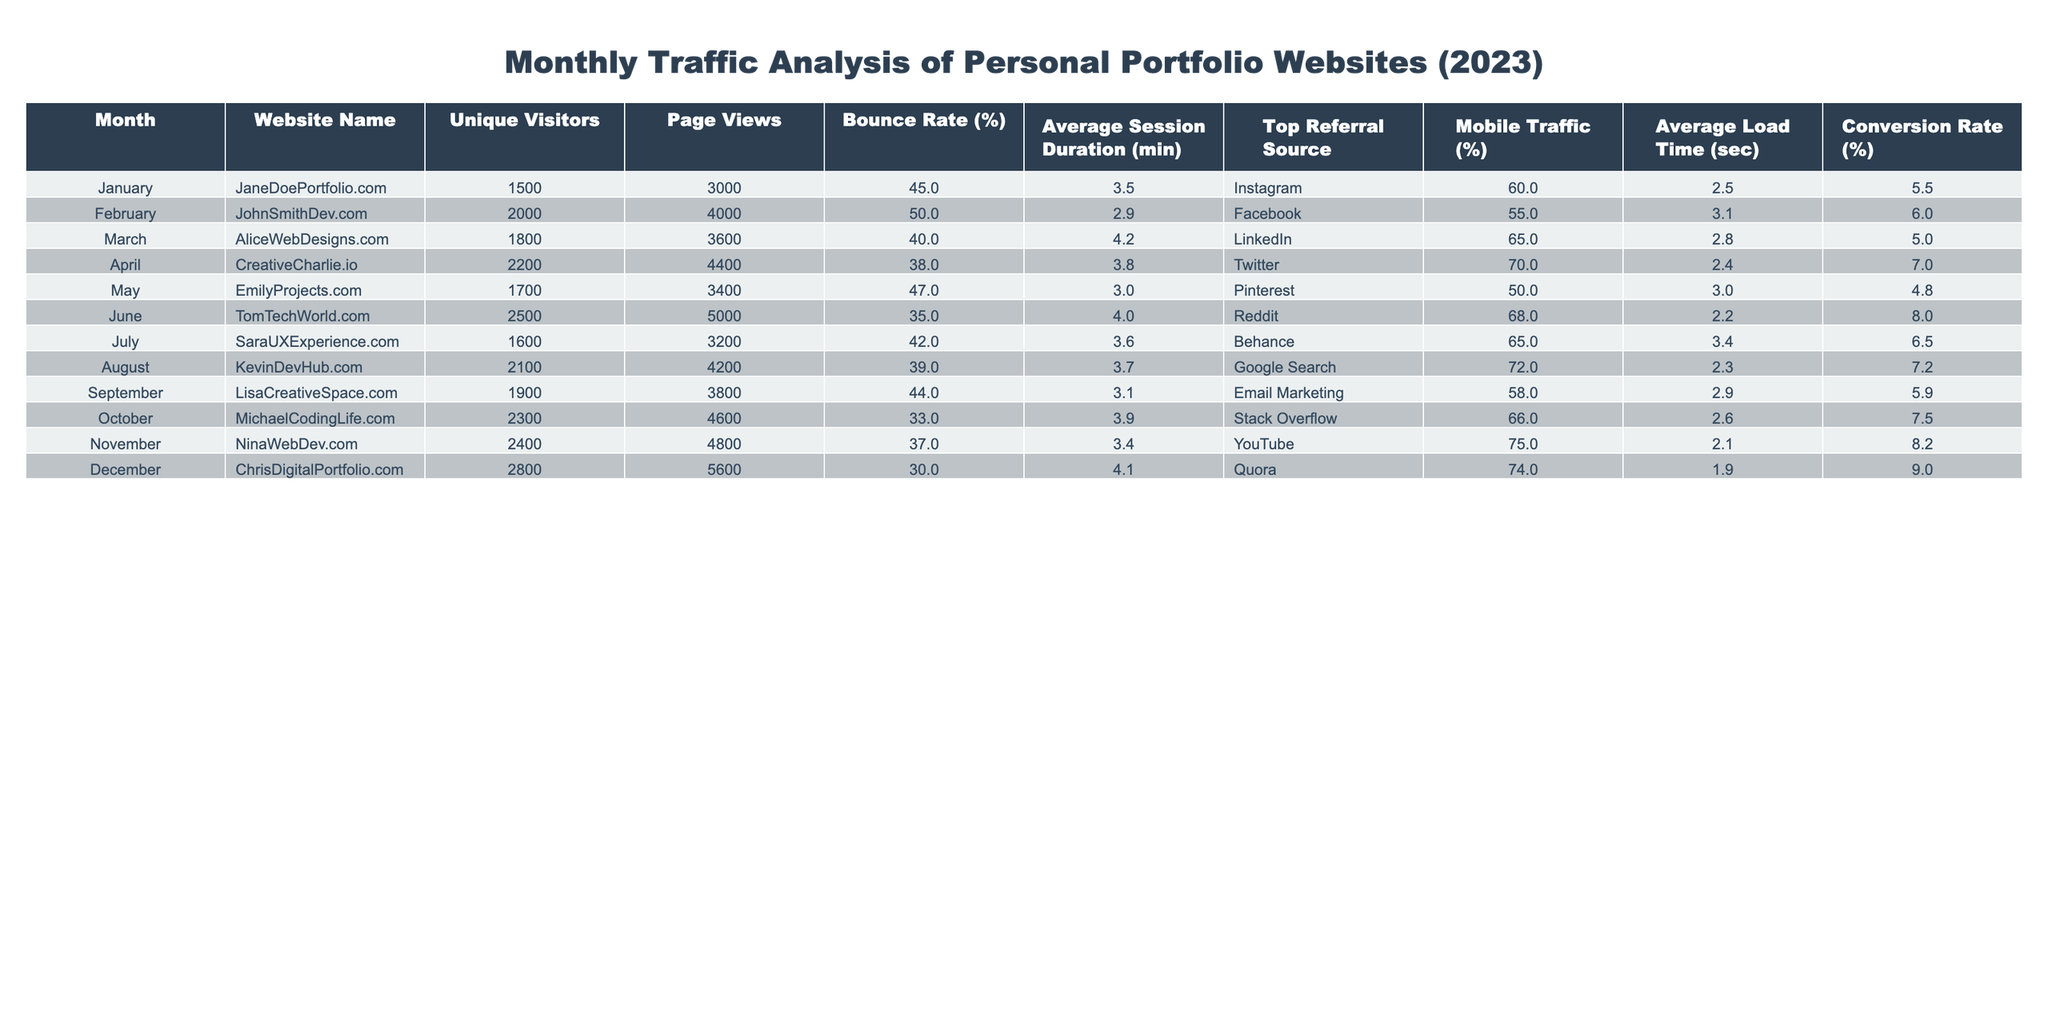What website had the highest unique visitors in December? Looking at the "Unique Visitors" column for December, ChrisDigitalPortfolio.com has 2800 unique visitors, which is the highest in that month compared to the other websites.
Answer: ChrisDigitalPortfolio.com What is the average bounce rate across all websites for the year? The bounce rates are 45, 50, 40, 38, 47, 35, 42, 39, 44, 33, 37, and 30 respectively. Adding these gives a total of  39.5, and dividing by 12 (the number of months) gives an average of 39.5%.
Answer: 39.5% Did any website have a conversion rate over 8%? By examining the "Conversion Rate (%)" column, we see that both June (8.0%) and December (9.0%) have conversion rates over 8%.
Answer: Yes What was the total number of page views for all websites combined in 2023? Summing the page views across all months: 3000 + 4000 + 3600 + 4400 + 3400 + 5000 + 3200 + 4200 + 3800 + 4600 + 4800 + 5600 equals 49,000.
Answer: 49000 Which month had the lowest average session duration? By examining the "Average Session Duration" column, May has the lowest value of 3.0 minutes among all months.
Answer: May What percentage of mobile traffic did MichaelCodingLife.com have compared to the highest percentage in the table? MichaelCodingLife.com has 66% mobile traffic, while the highest is for CreativeCharlie.io at 70%. The difference is 70 - 66 = 4%.
Answer: 4% Which website had the highest mobile traffic and what was that percentage? Checking the "Mobile Traffic (%)" column, we see that NinaWebDev.com has the highest mobile traffic at 75%.
Answer: 75% What was the average load time for the top three websites by unique visitors in December? The top three websites with unique visitors in December are ChrisDigitalPortfolio.com (1.9 sec), NinaWebDev.com (2.1 sec), and MichaelCodingLife.com (2.6 sec). Their average load time is (1.9 + 2.1 + 2.6) / 3 = 2.2 sec.
Answer: 2.2 seconds How does the bounce rate for EmilyProjects.com compare to the average bounce rate for all websites? The bounce rate for EmilyProjects.com is 47%. The average bounce rate for all websites, as previously calculated, is 39.5%. Since 47% is higher than 39.5%, we note that EmilyProjects.com has a higher bounce rate.
Answer: Higher What was the difference in unique visitors between LisaCreativeSpace.com and SaraUXExperience.com? LisaCreativeSpace.com had 1900 unique visitors, and SaraUXExperience.com had 1600 unique visitors. The difference is 1900 - 1600 = 300.
Answer: 300 